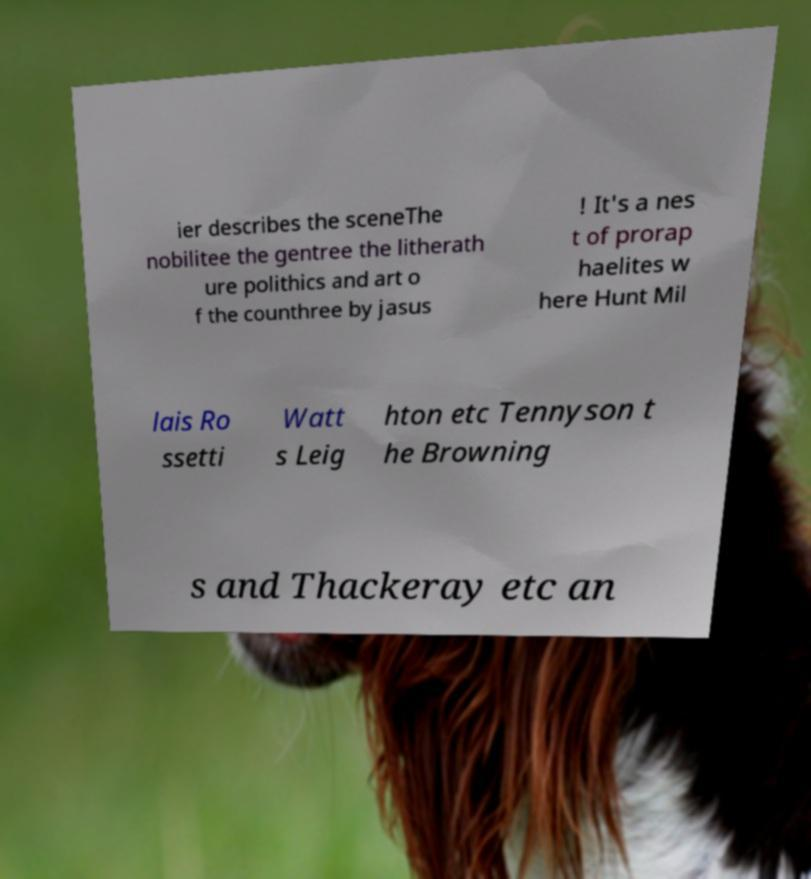There's text embedded in this image that I need extracted. Can you transcribe it verbatim? ier describes the sceneThe nobilitee the gentree the litherath ure polithics and art o f the counthree by jasus ! It's a nes t of prorap haelites w here Hunt Mil lais Ro ssetti Watt s Leig hton etc Tennyson t he Browning s and Thackeray etc an 